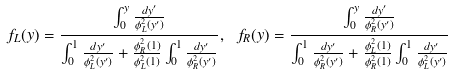<formula> <loc_0><loc_0><loc_500><loc_500>f _ { L } ( y ) = \frac { \int _ { 0 } ^ { y } \frac { d y ^ { \prime } } { \phi _ { L } ^ { 2 } ( y ^ { \prime } ) } } { \int _ { 0 } ^ { 1 } \frac { d y ^ { \prime } } { \phi _ { L } ^ { 2 } ( y ^ { \prime } ) } + \frac { \phi _ { R } ^ { 2 } ( 1 ) } { \phi _ { L } ^ { 2 } ( 1 ) } \int _ { 0 } ^ { 1 } \frac { d y ^ { \prime } } { \phi _ { R } ^ { 2 } ( y ^ { \prime } ) } } , \ f _ { R } ( y ) = \frac { \int _ { 0 } ^ { y } \frac { d y ^ { \prime } } { \phi _ { R } ^ { 2 } ( y ^ { \prime } ) } } { \int _ { 0 } ^ { 1 } \frac { d y ^ { \prime } } { \phi _ { R } ^ { 2 } ( y ^ { \prime } ) } + \frac { \phi _ { L } ^ { 2 } ( 1 ) } { \phi _ { R } ^ { 2 } ( 1 ) } \int _ { 0 } ^ { 1 } \frac { d y ^ { \prime } } { \phi _ { L } ^ { 2 } ( y ^ { \prime } ) } }</formula> 